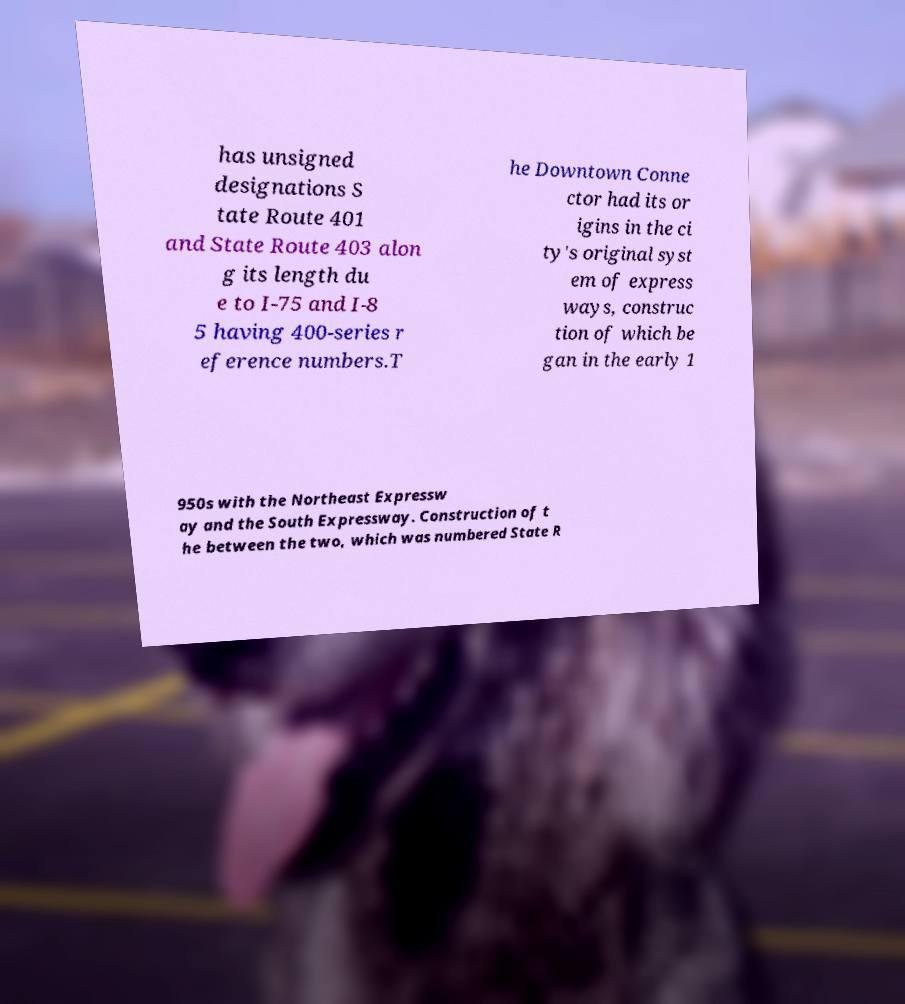There's text embedded in this image that I need extracted. Can you transcribe it verbatim? has unsigned designations S tate Route 401 and State Route 403 alon g its length du e to I-75 and I-8 5 having 400-series r eference numbers.T he Downtown Conne ctor had its or igins in the ci ty's original syst em of express ways, construc tion of which be gan in the early 1 950s with the Northeast Expressw ay and the South Expressway. Construction of t he between the two, which was numbered State R 